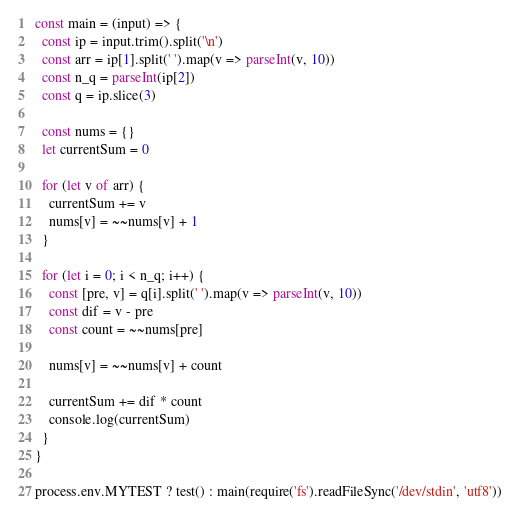Convert code to text. <code><loc_0><loc_0><loc_500><loc_500><_JavaScript_>
const main = (input) => {
  const ip = input.trim().split('\n')
  const arr = ip[1].split(' ').map(v => parseInt(v, 10))
  const n_q = parseInt(ip[2])
  const q = ip.slice(3)

  const nums = {}
  let currentSum = 0
  
  for (let v of arr) {
    currentSum += v
    nums[v] = ~~nums[v] + 1
  }

  for (let i = 0; i < n_q; i++) {
    const [pre, v] = q[i].split(' ').map(v => parseInt(v, 10))
    const dif = v - pre
    const count = ~~nums[pre]

    nums[v] = ~~nums[v] + count

    currentSum += dif * count
    console.log(currentSum)
  }
}

process.env.MYTEST ? test() : main(require('fs').readFileSync('/dev/stdin', 'utf8'))</code> 